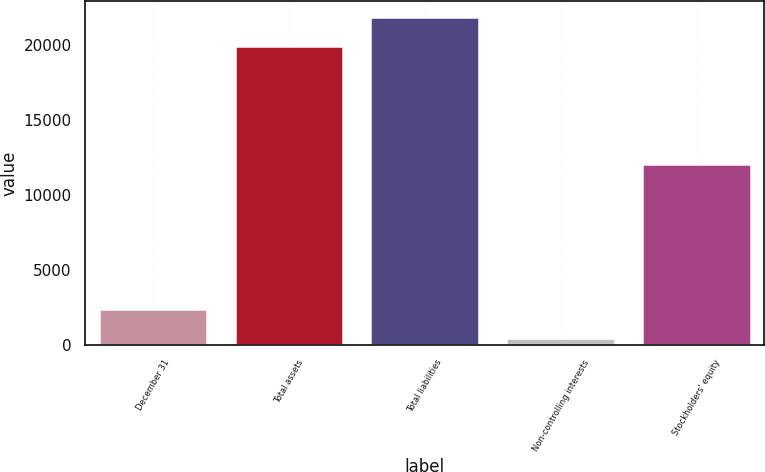<chart> <loc_0><loc_0><loc_500><loc_500><bar_chart><fcel>December 31<fcel>Total assets<fcel>Total liabilities<fcel>Non-controlling interests<fcel>Stockholders' equity<nl><fcel>2434.3<fcel>19924<fcel>21867.3<fcel>491<fcel>12069<nl></chart> 